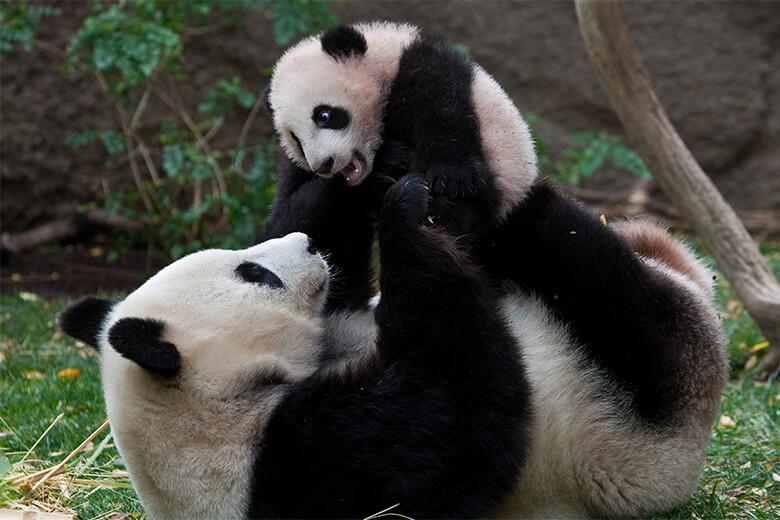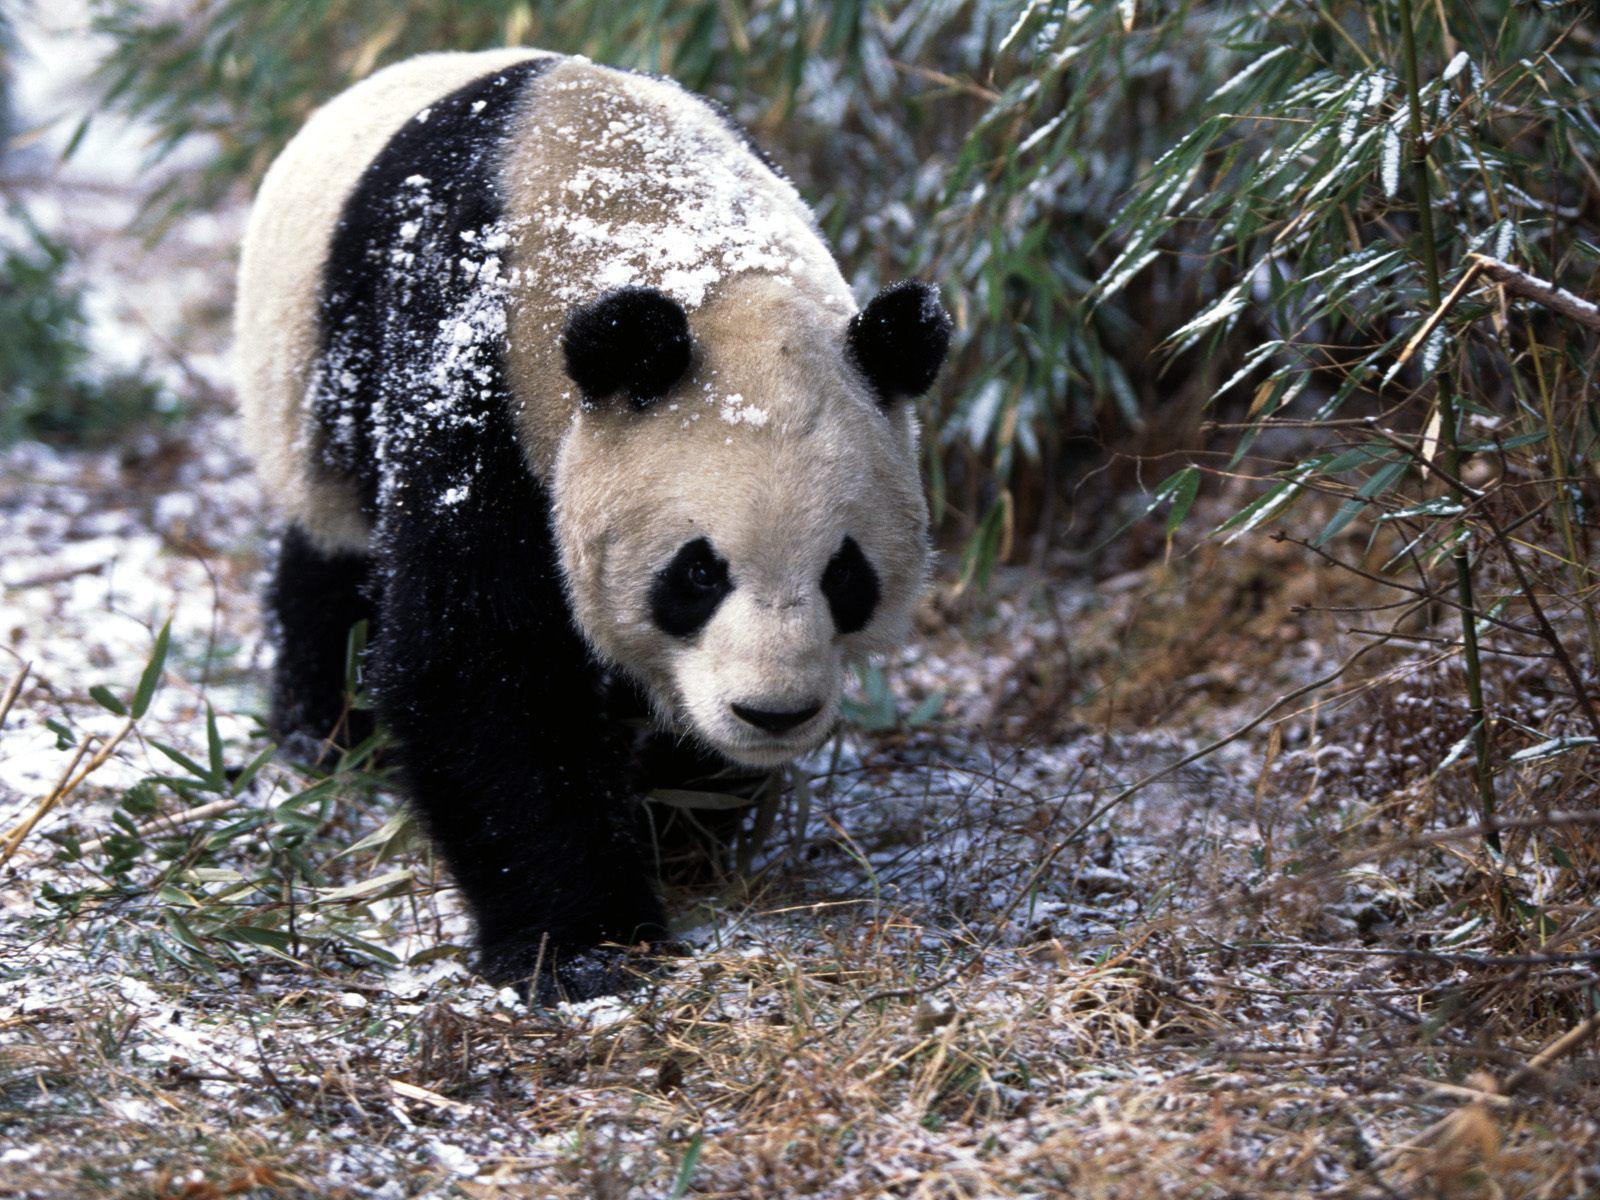The first image is the image on the left, the second image is the image on the right. Given the left and right images, does the statement "In one of the images there are exactly two pandas cuddled together." hold true? Answer yes or no. Yes. The first image is the image on the left, the second image is the image on the right. Evaluate the accuracy of this statement regarding the images: "Two pandas are on top of each other in one of the images.". Is it true? Answer yes or no. Yes. 